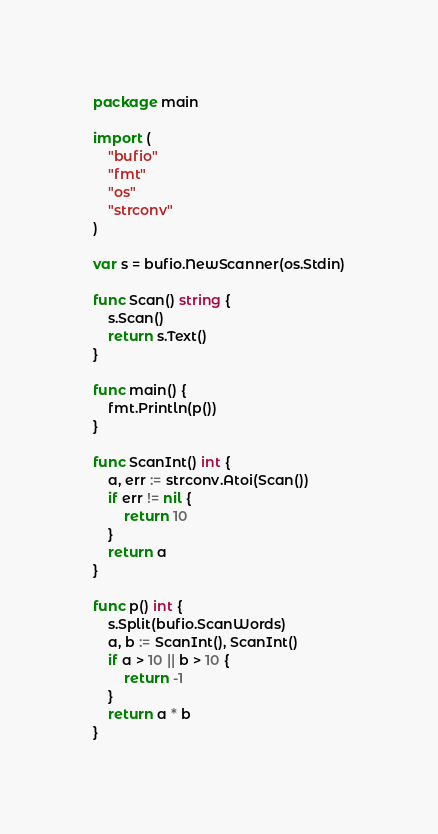Convert code to text. <code><loc_0><loc_0><loc_500><loc_500><_Go_>package main

import (
	"bufio"
	"fmt"
	"os"
	"strconv"
)

var s = bufio.NewScanner(os.Stdin)

func Scan() string {
	s.Scan()
	return s.Text()
}

func main() {
	fmt.Println(p())
}

func ScanInt() int {
	a, err := strconv.Atoi(Scan())
	if err != nil {
		return 10
	}
	return a
}

func p() int {
	s.Split(bufio.ScanWords)
	a, b := ScanInt(), ScanInt()
	if a > 10 || b > 10 {
		return -1
	}
	return a * b
}
</code> 